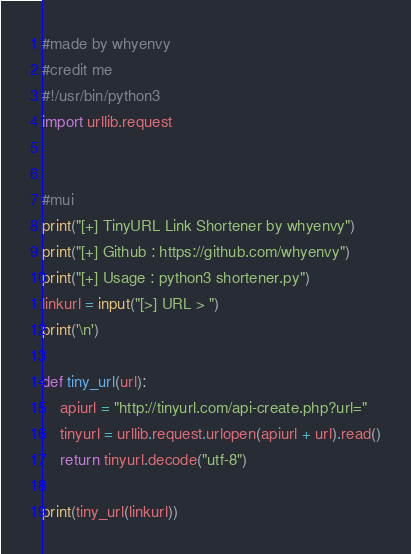Convert code to text. <code><loc_0><loc_0><loc_500><loc_500><_Python_>#made by whyenvy
#credit me
#!/usr/bin/python3
import urllib.request


#mui
print("[+] TinyURL Link Shortener by whyenvy")
print("[+] Github : https://github.com/whyenvy")
print("[+] Usage : python3 shortener.py")
linkurl = input("[>] URL > ")
print('\n')

def tiny_url(url):
    apiurl = "http://tinyurl.com/api-create.php?url="
    tinyurl = urllib.request.urlopen(apiurl + url).read()
    return tinyurl.decode("utf-8")

print(tiny_url(linkurl))
</code> 